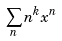Convert formula to latex. <formula><loc_0><loc_0><loc_500><loc_500>\sum _ { n } n ^ { k } x ^ { n }</formula> 